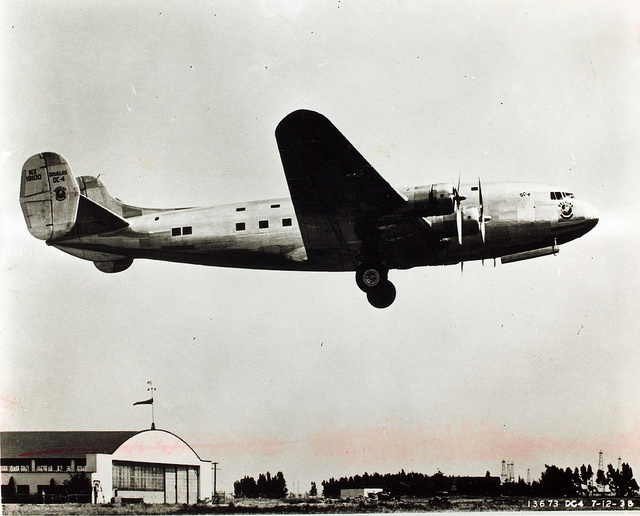Describe the objects in this image and their specific colors. I can see a airplane in white, black, lightgray, gray, and darkgray tones in this image. 